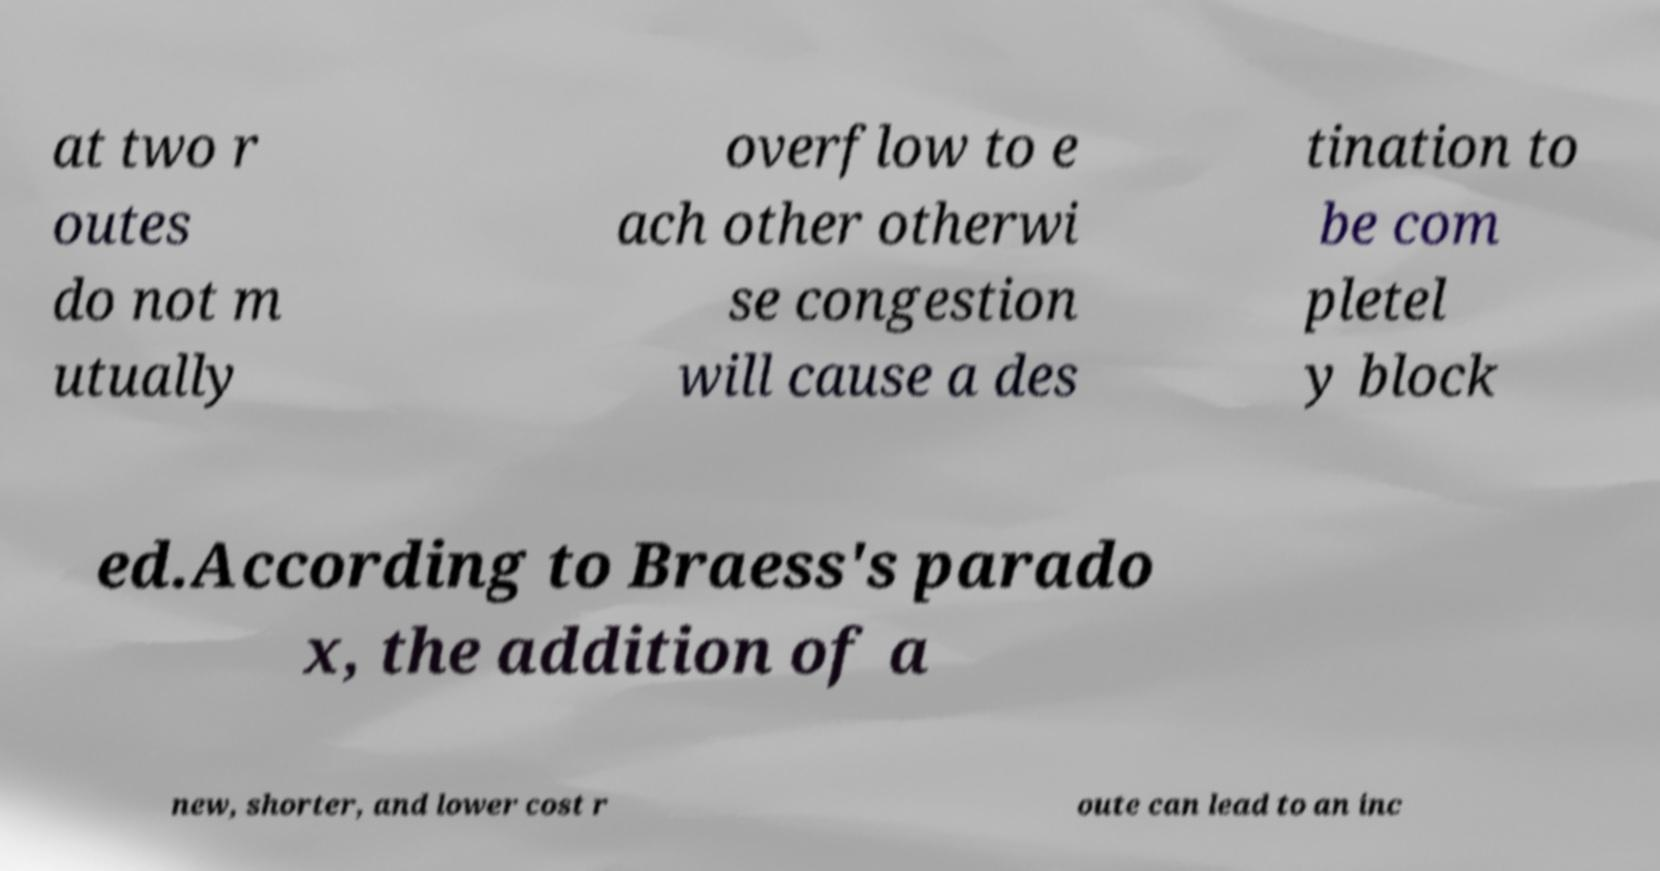Please identify and transcribe the text found in this image. at two r outes do not m utually overflow to e ach other otherwi se congestion will cause a des tination to be com pletel y block ed.According to Braess's parado x, the addition of a new, shorter, and lower cost r oute can lead to an inc 